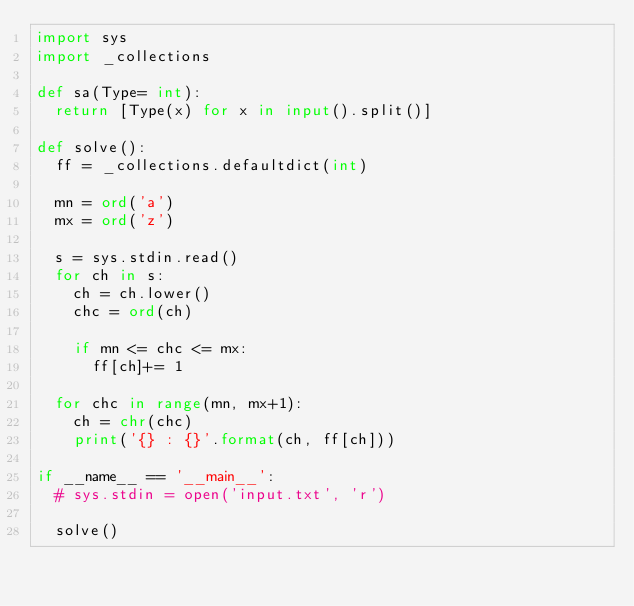Convert code to text. <code><loc_0><loc_0><loc_500><loc_500><_Python_>import sys
import _collections

def sa(Type= int):
  return [Type(x) for x in input().split()]

def solve():
  ff = _collections.defaultdict(int)

  mn = ord('a')
  mx = ord('z')

  s = sys.stdin.read()
  for ch in s:
    ch = ch.lower()
    chc = ord(ch)

    if mn <= chc <= mx:
      ff[ch]+= 1

  for chc in range(mn, mx+1):
    ch = chr(chc)
    print('{} : {}'.format(ch, ff[ch]))

if __name__ == '__main__':
  # sys.stdin = open('input.txt', 'r')

  solve()
</code> 